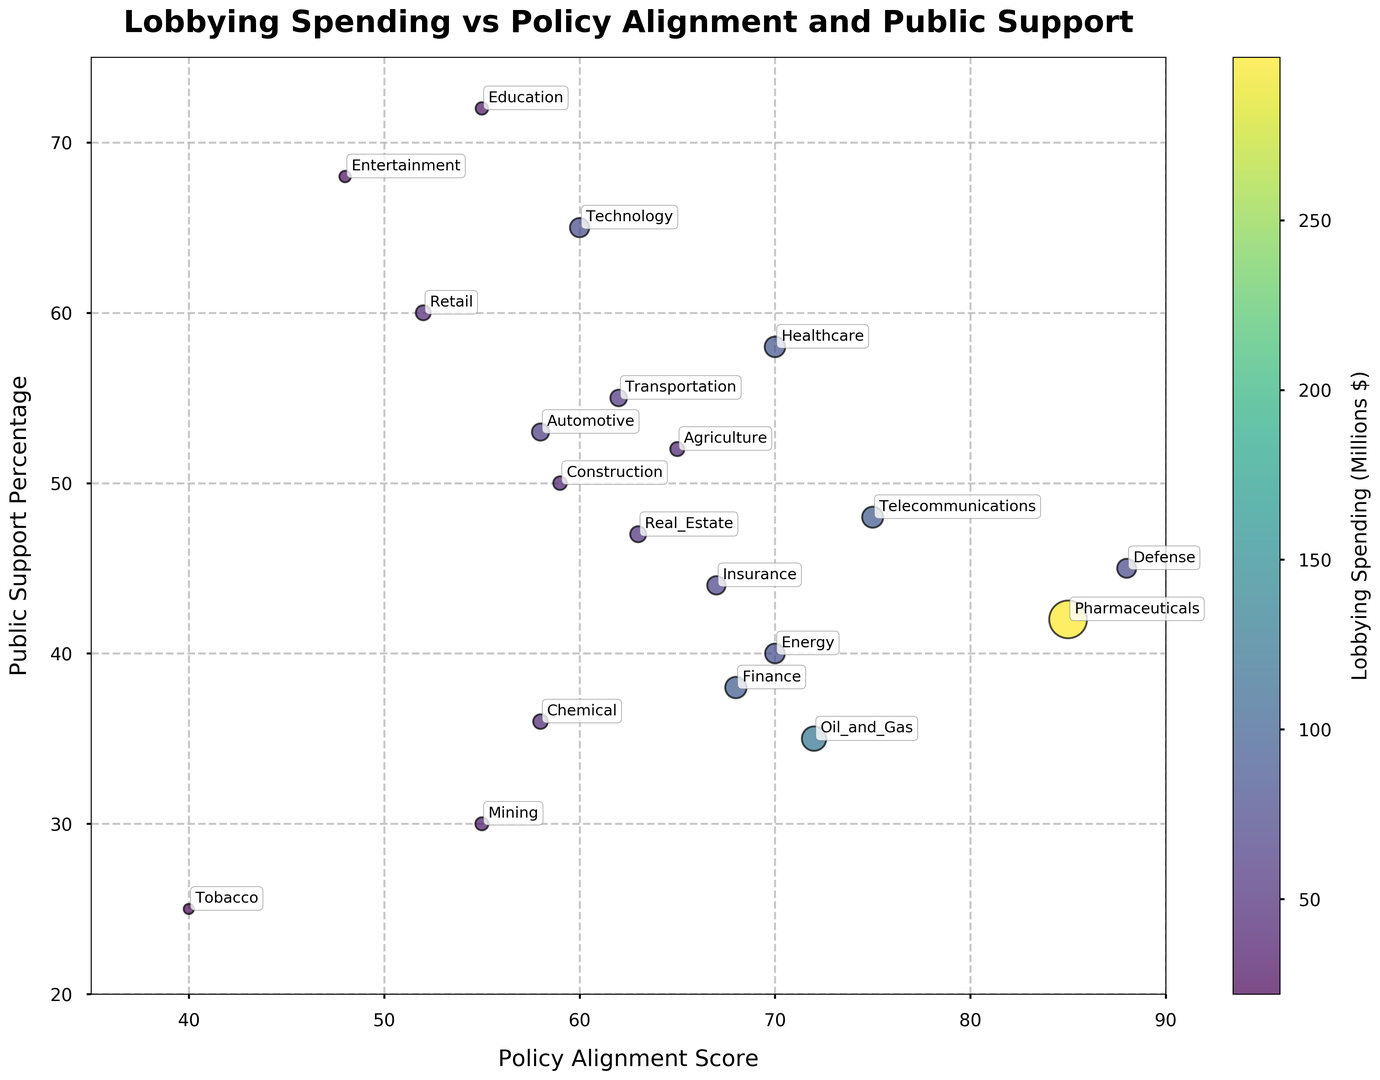What is the industry with the highest policy alignment score? The highest policy alignment score pertains to the value on the x-axis closest to 90. According to the chart, the industry near this score is Defense, which has a policy alignment score of 88.
Answer: Defense Which industry has the smallest bubble size and what does it represent? The smallest bubble size represents the industry with the least lobbying spending. From the figure, the smallest bubble is for Tobacco, indicating it spends the least on lobbying, which is $22 million.
Answer: Tobacco How does the public support percentage for Pharmaceuticals compare with its policy alignment score? By evaluating the figure, Pharmaceuticals are represented by the bubble closest to the upper-right corner. The public support percentage for Pharmaceuticals is lower than its policy alignment score, with values of 42% and 85% respectively.
Answer: Lower Which industry has the closest balance between its lobbying spending and public support percentage? The industry with closely matching lobbying spending (as indicated by bubble size) and public support percentage (y-axis) needs to be determined by visual inspection. Telecommunications appears balanced, with lobbying at $93 million and public support at 48%.
Answer: Telecommunications What industries have a policy alignment score greater than 70 and public support above 45%? By looking at the bubbles located above the y = 45 line and to the right of the x = 70 line: Pharmaceuticals, Defense, and Telecommunications meet both criteria.
Answer: Pharmaceuticals, Defense, Telecommunications What is the combined lobbying spending of the top three industries in terms of lobbying spending? The top three largest bubbles are Pharmaceuticals, Oil and Gas, and Finance, with spending of $298 million, $125 million, and $96 million, respectively. Combined, this sums to 298 + 125 + 96 = 519.
Answer: 519 Which industry has the highest public support and how much does it spend on lobbying? The highest public support percentage is the value closest to 75 on the y-axis. Education has the highest public support at 72%. It spends $33 million on lobbying according to its bubble size.
Answer: Education Is there any industry with a policy alignment score less than 55 but with public support above 50%? Evaluating the bubbles to the left of the x = 55 line and above the y = 50 line, Entertainment stands out with a policy alignment score of 48 and public support of 68%.
Answer: Entertainment 